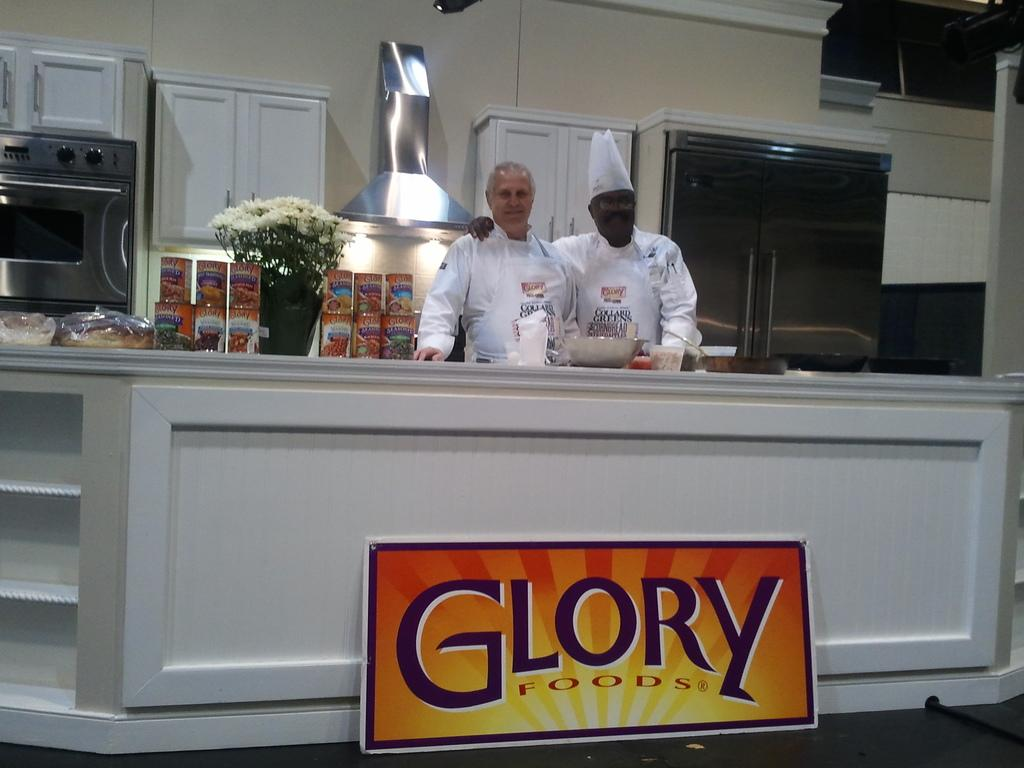Provide a one-sentence caption for the provided image. Two chefs proudly stand behind a counter belwo which is a sign for Glory Foods. 